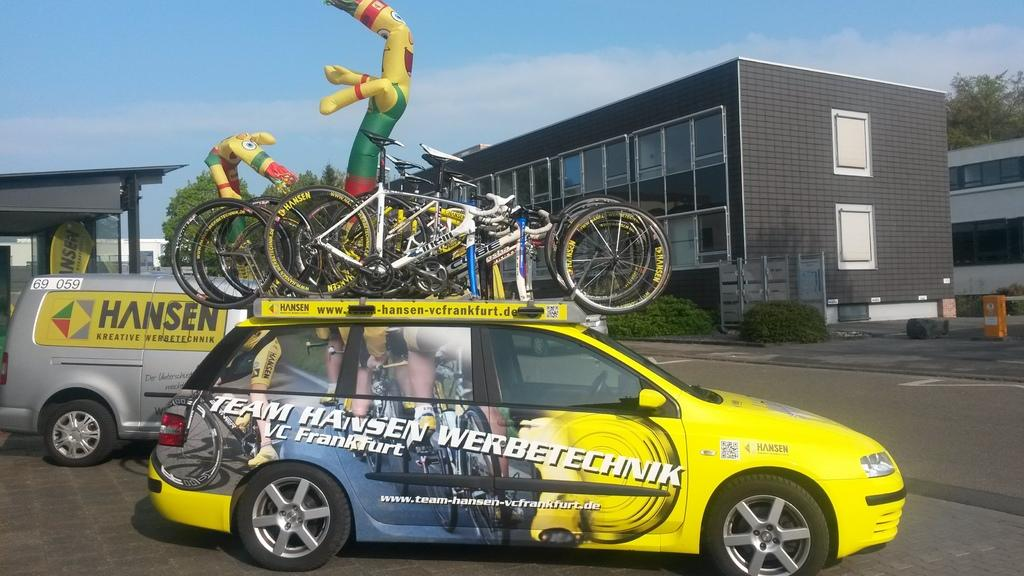<image>
Render a clear and concise summary of the photo. The Team Hansen car has many bicycles on the roof. 